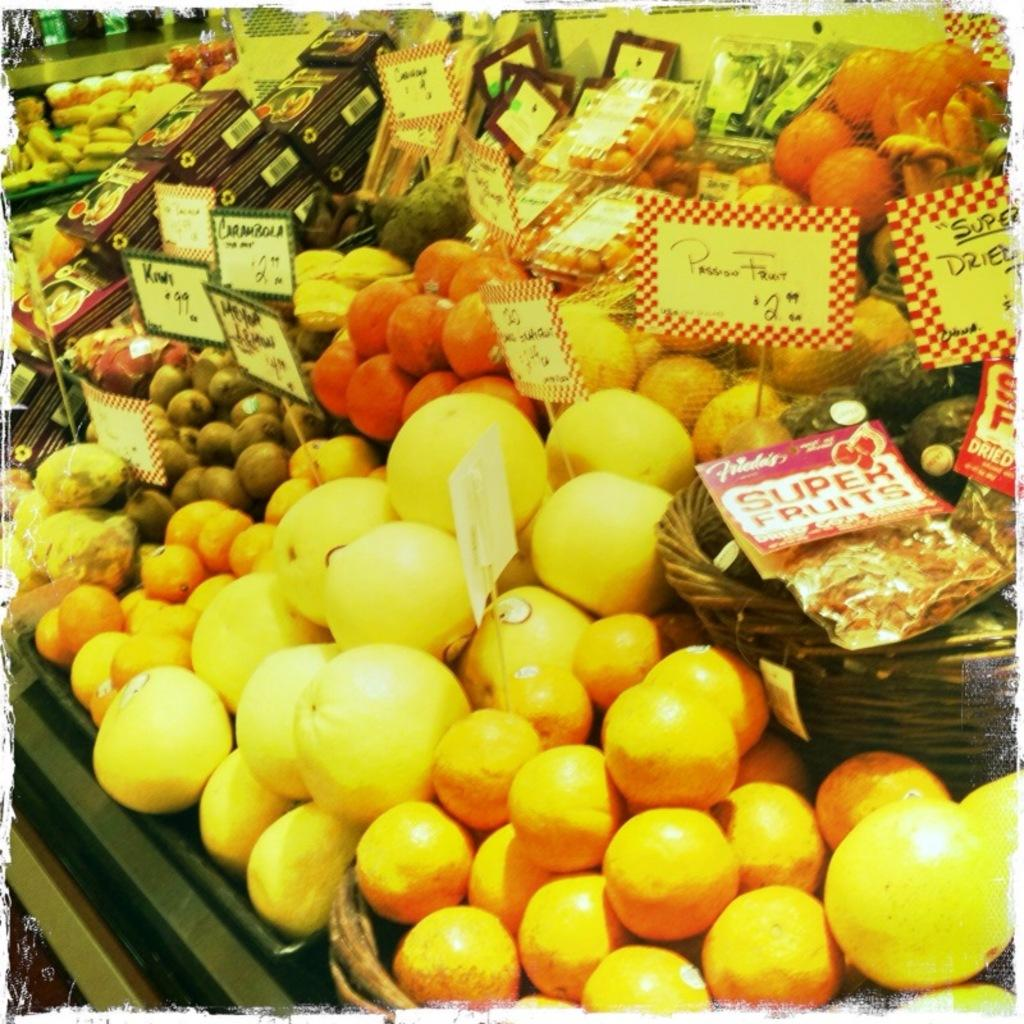What types of objects are present in the image? There are different types of fruits in the image. How can we identify the types of fruits in the image? The fruits have name boards associated with them. Are there any other objects present in the image besides the fruits? Yes, there are other objects present in the image. How many bells can be heard ringing in the image? There are no bells present in the image, so we cannot hear any ringing. 